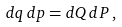<formula> <loc_0><loc_0><loc_500><loc_500>d q \, d p = d Q \, d P \, ,</formula> 